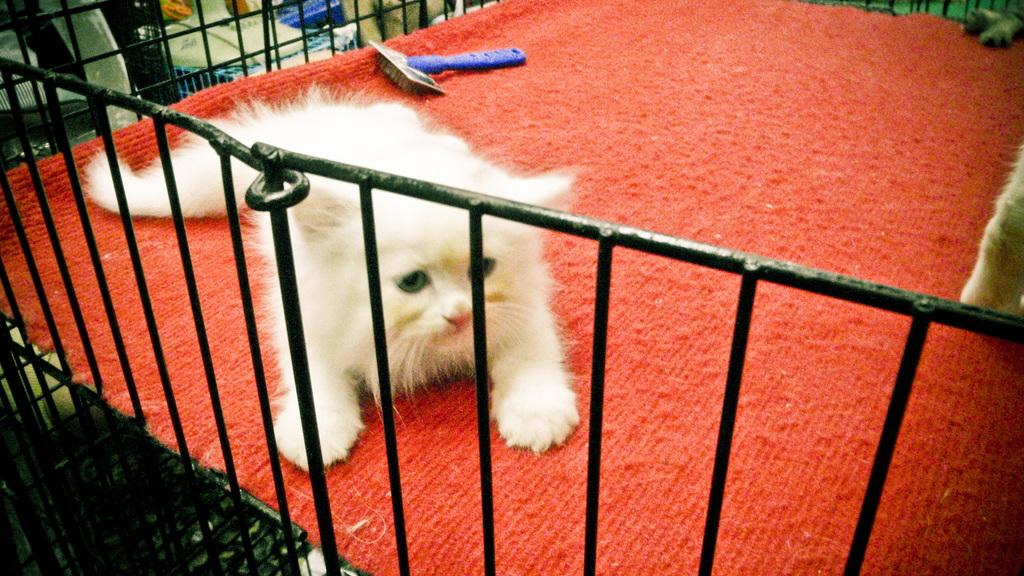What type of animal is in the image? There is a white color cat in the image. What is the cat sitting on? The cat is on a red color carpet. What other object can be seen in the image? There is a railing in the image. What is the color of the railing? The railing is black in color. What type of prose is the cat reading on the red carpet? There is no prose present in the image, as the cat is not reading anything. 